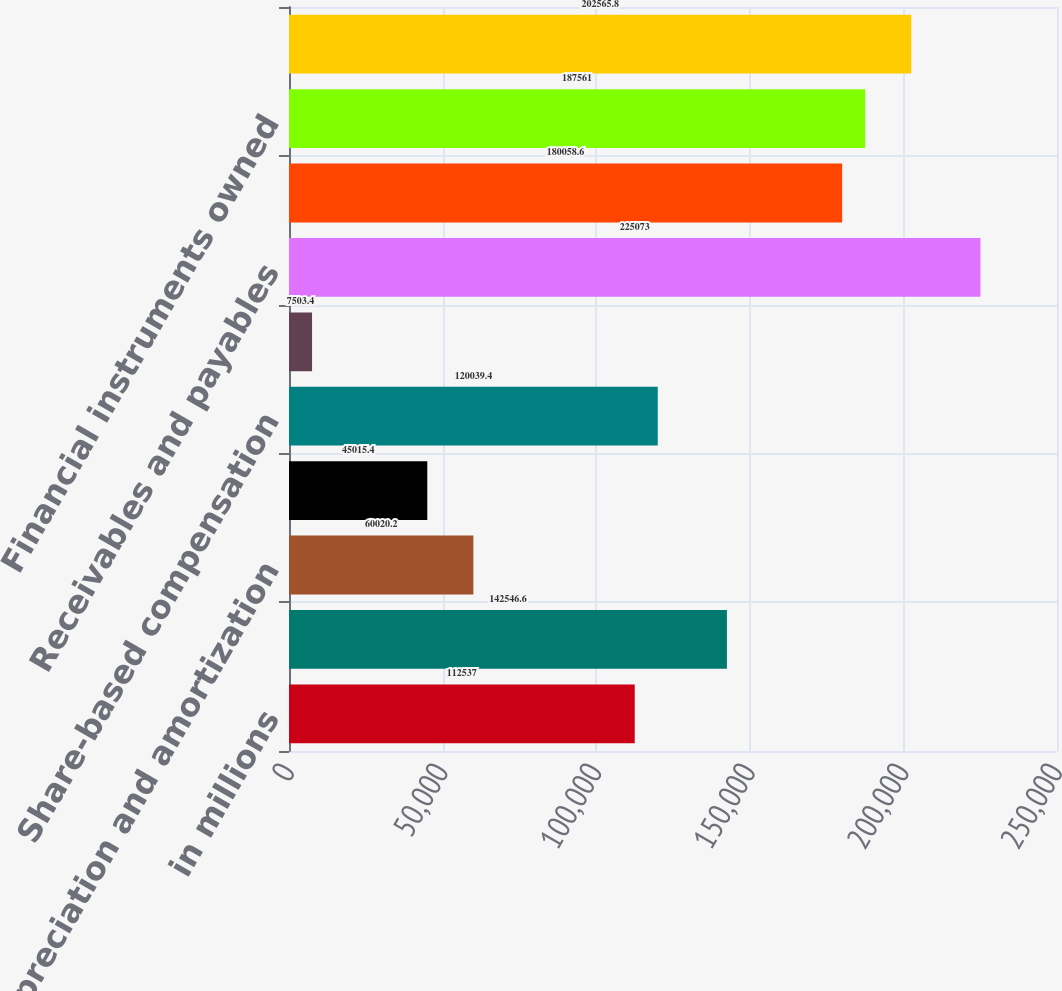<chart> <loc_0><loc_0><loc_500><loc_500><bar_chart><fcel>in millions<fcel>Net earnings<fcel>Depreciation and amortization<fcel>Deferred income taxes<fcel>Share-based compensation<fcel>Loss/(gain) related to<fcel>Receivables and payables<fcel>Collateralized transactions<fcel>Financial instruments owned<fcel>Financial instruments sold but<nl><fcel>112537<fcel>142547<fcel>60020.2<fcel>45015.4<fcel>120039<fcel>7503.4<fcel>225073<fcel>180059<fcel>187561<fcel>202566<nl></chart> 